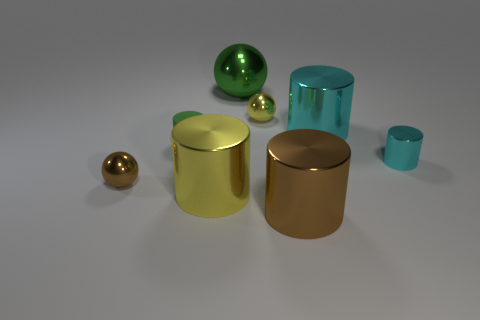Subtract 1 cylinders. How many cylinders are left? 4 Subtract all gray cylinders. Subtract all gray spheres. How many cylinders are left? 5 Add 1 small yellow things. How many objects exist? 9 Subtract all spheres. How many objects are left? 5 Subtract all tiny gray cylinders. Subtract all small metallic spheres. How many objects are left? 6 Add 7 large green shiny spheres. How many large green shiny spheres are left? 8 Add 4 yellow metal spheres. How many yellow metal spheres exist? 5 Subtract 0 cyan cubes. How many objects are left? 8 